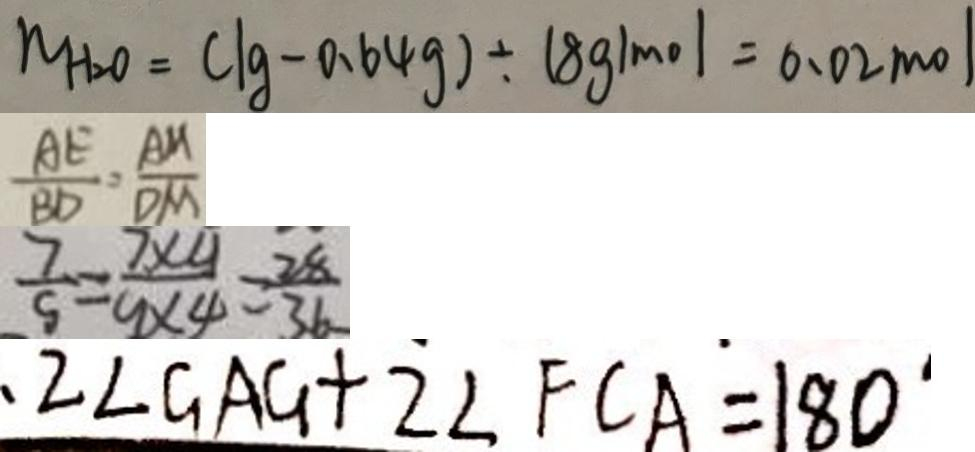Convert formula to latex. <formula><loc_0><loc_0><loc_500><loc_500>N H _ { 2 } O = ( \lg - 0 . 6 4 g ) \div 1 8 g / m o l = 0 . 0 2 m o l 
 \frac { A E } { B D } = \frac { A M } { D M } 
 \frac { 7 } { 5 } = \frac { 7 \times 4 } { 9 \times 4 } = \frac { 2 8 } { 3 6 } 
 2 \angle G A G + 2 \angle F C A = 1 8 0 ^ { \circ }</formula> 